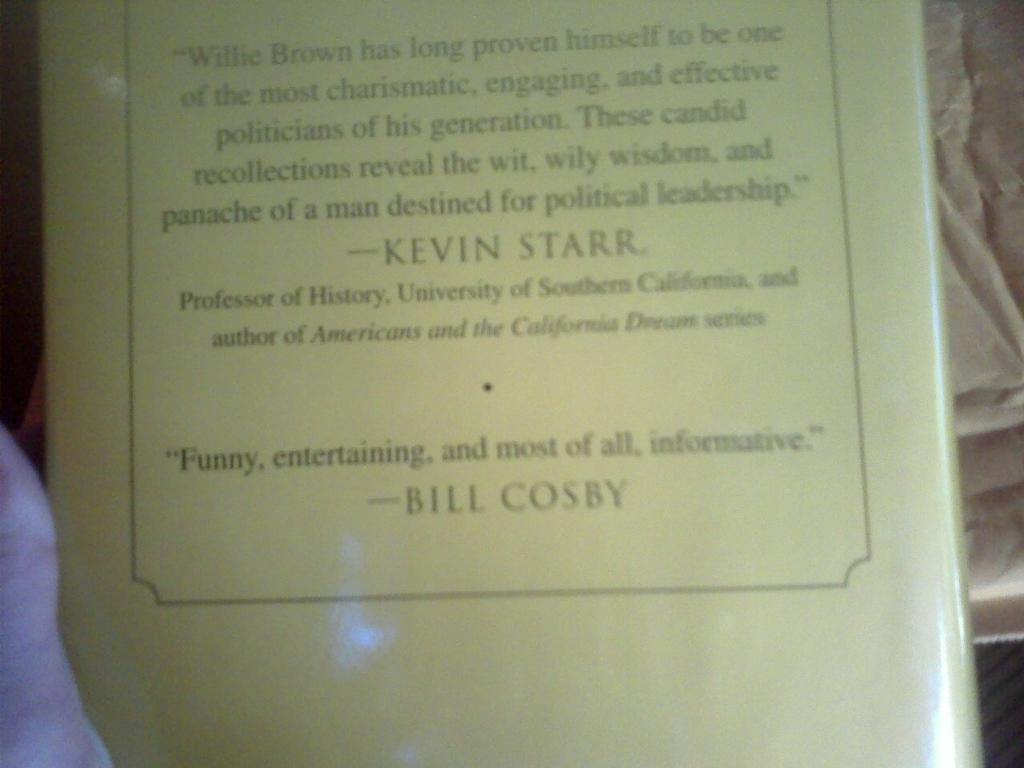Provide a one-sentence caption for the provided image. the back of a book with reviews from Kevin Starr and Bill Cosby. 